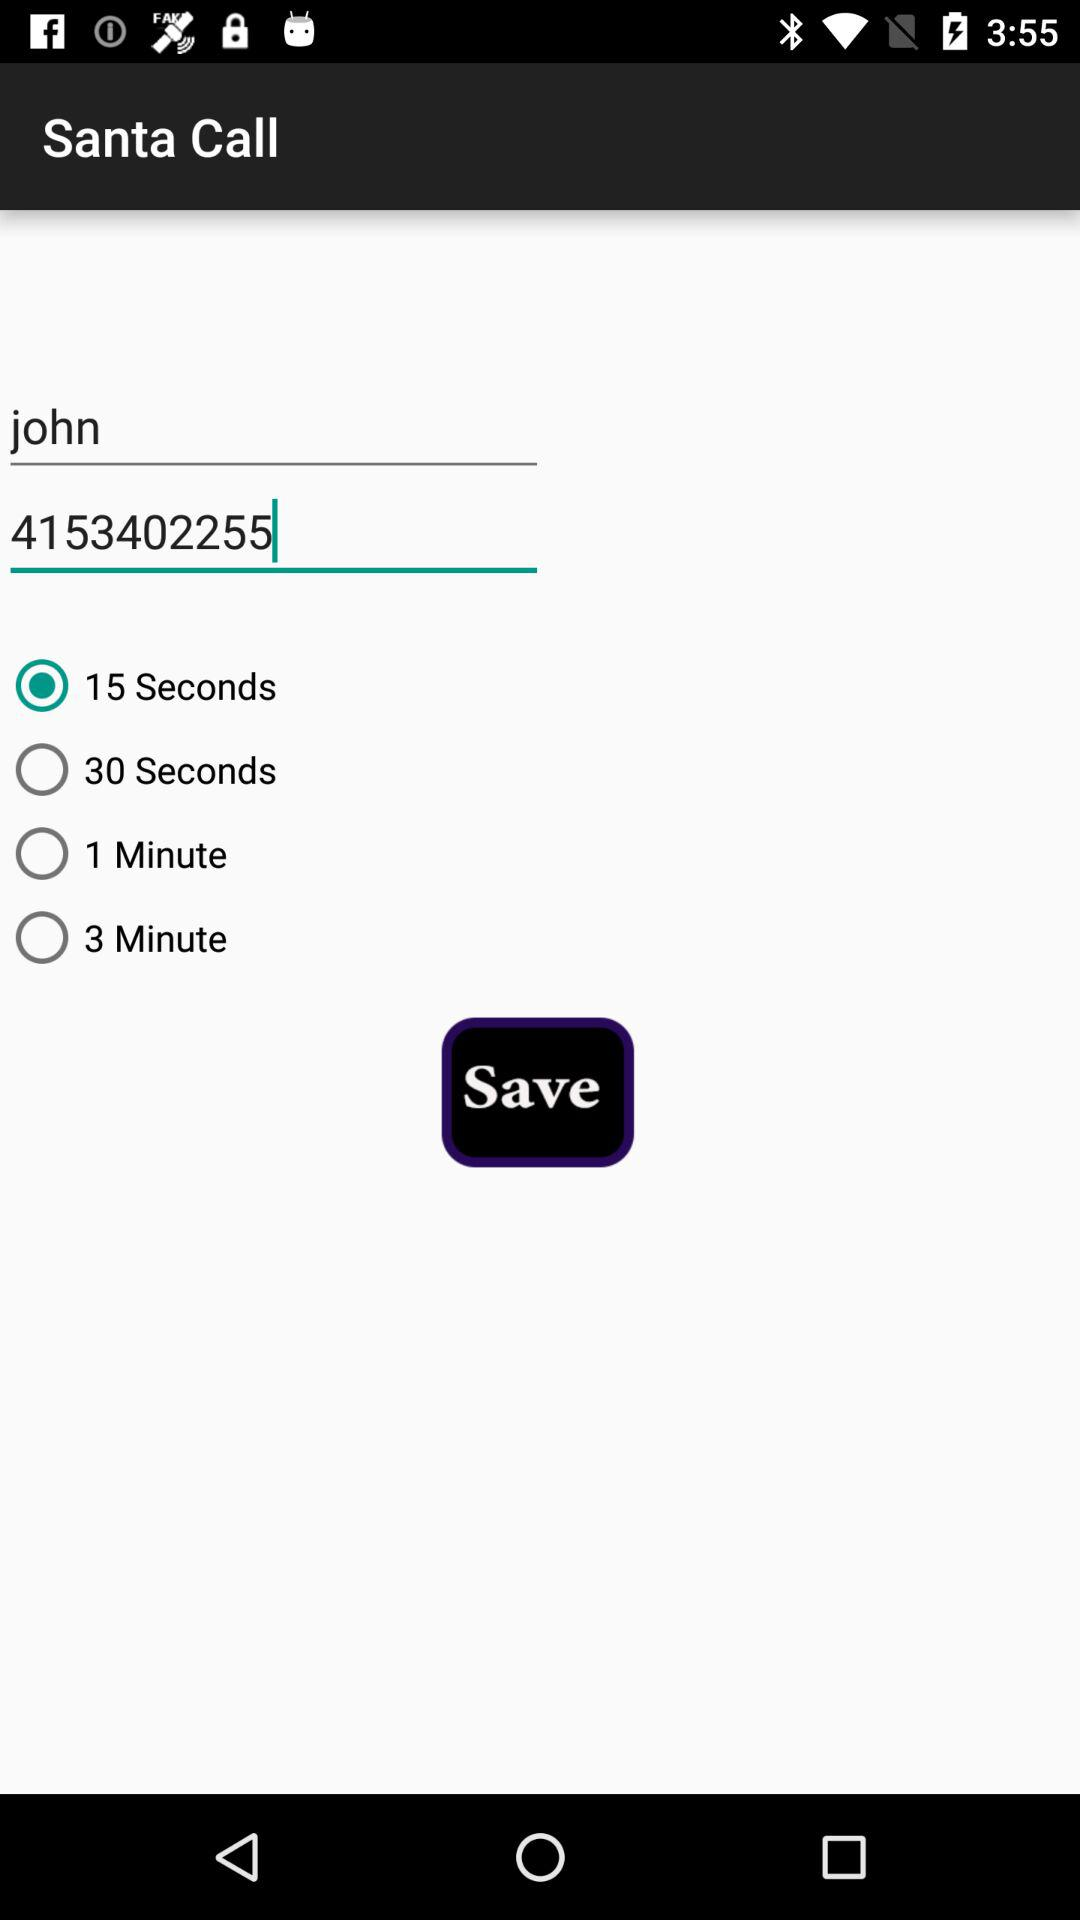What is the application name? The application name is "Santa Call". 